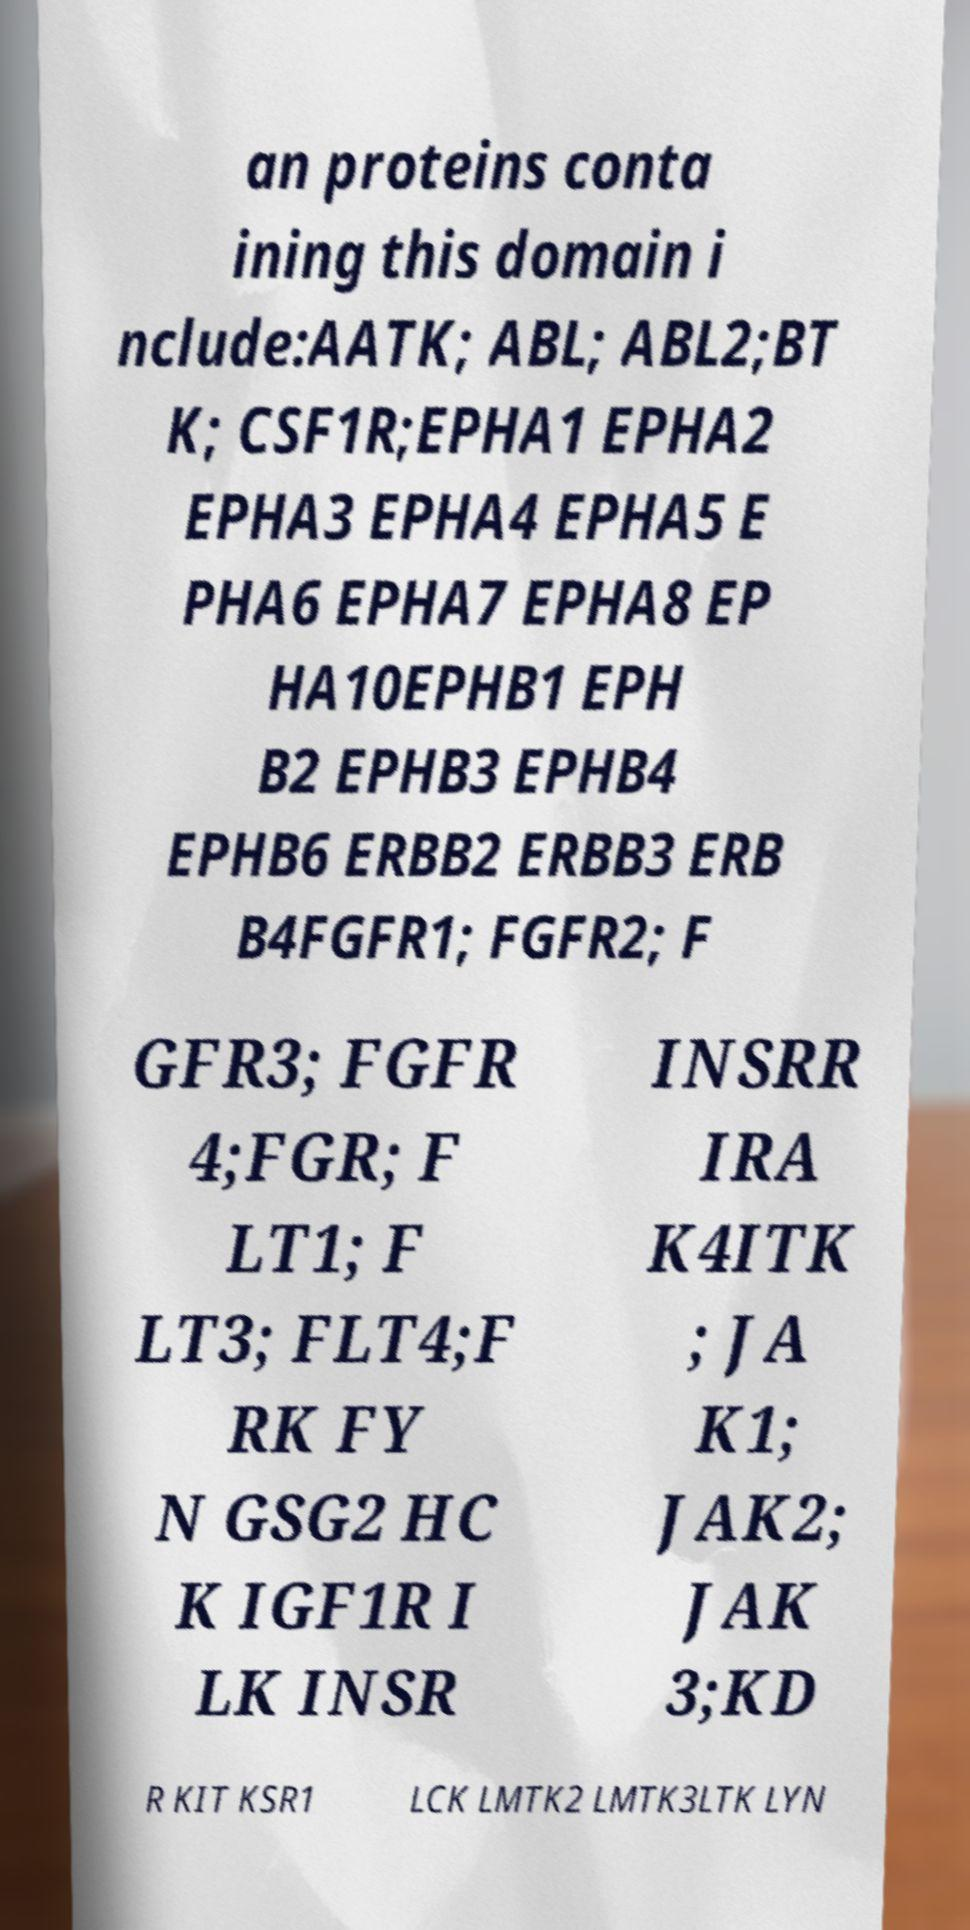Please read and relay the text visible in this image. What does it say? an proteins conta ining this domain i nclude:AATK; ABL; ABL2;BT K; CSF1R;EPHA1 EPHA2 EPHA3 EPHA4 EPHA5 E PHA6 EPHA7 EPHA8 EP HA10EPHB1 EPH B2 EPHB3 EPHB4 EPHB6 ERBB2 ERBB3 ERB B4FGFR1; FGFR2; F GFR3; FGFR 4;FGR; F LT1; F LT3; FLT4;F RK FY N GSG2 HC K IGF1R I LK INSR INSRR IRA K4ITK ; JA K1; JAK2; JAK 3;KD R KIT KSR1 LCK LMTK2 LMTK3LTK LYN 